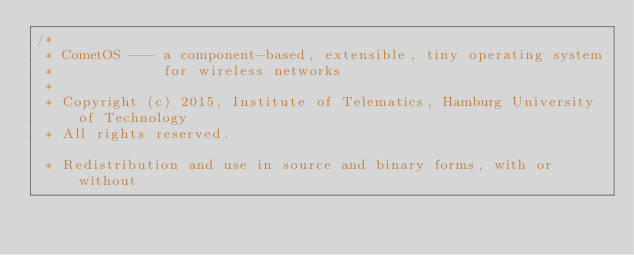<code> <loc_0><loc_0><loc_500><loc_500><_C++_>/*
 * CometOS --- a component-based, extensible, tiny operating system
 *             for wireless networks
 *
 * Copyright (c) 2015, Institute of Telematics, Hamburg University of Technology
 * All rights reserved.

 * Redistribution and use in source and binary forms, with or without</code> 